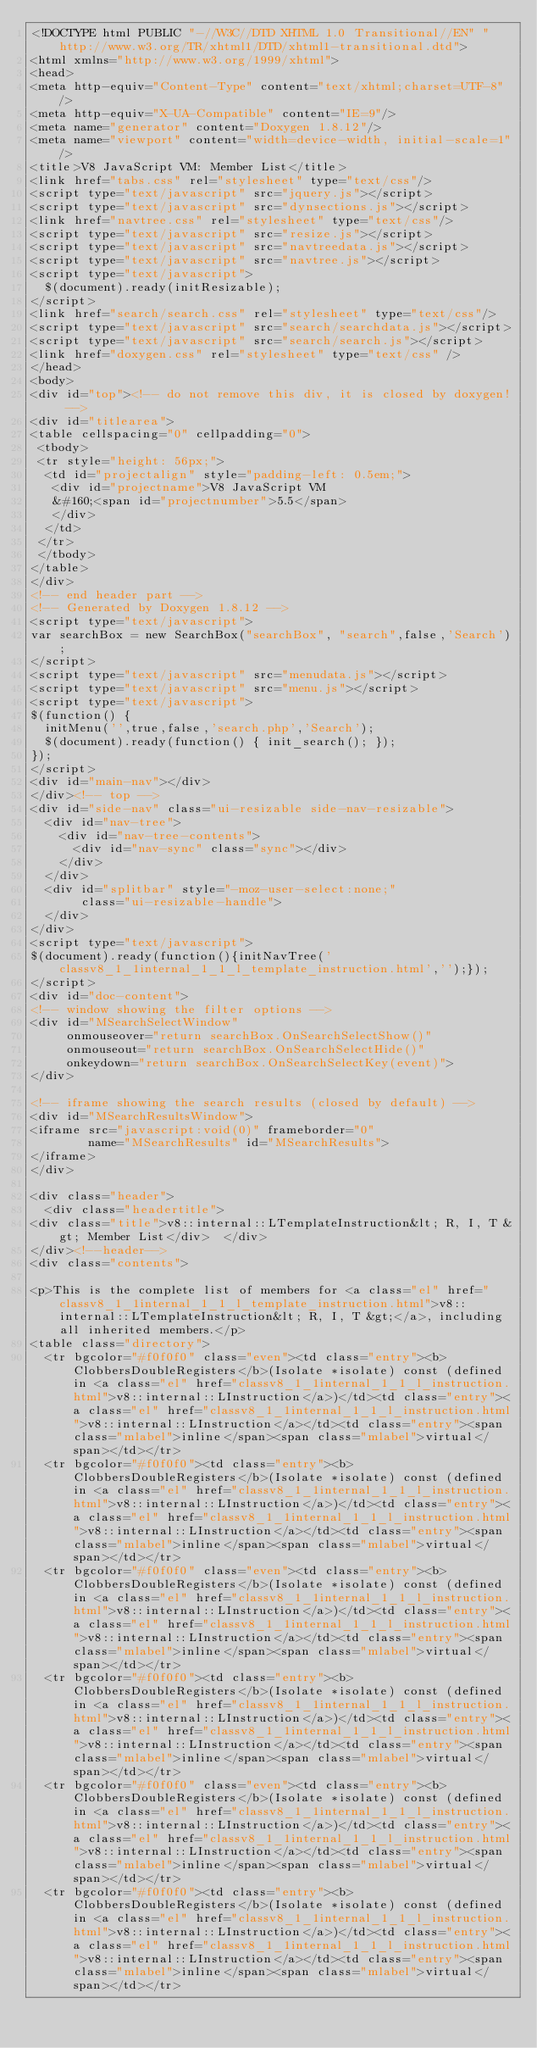Convert code to text. <code><loc_0><loc_0><loc_500><loc_500><_HTML_><!DOCTYPE html PUBLIC "-//W3C//DTD XHTML 1.0 Transitional//EN" "http://www.w3.org/TR/xhtml1/DTD/xhtml1-transitional.dtd">
<html xmlns="http://www.w3.org/1999/xhtml">
<head>
<meta http-equiv="Content-Type" content="text/xhtml;charset=UTF-8"/>
<meta http-equiv="X-UA-Compatible" content="IE=9"/>
<meta name="generator" content="Doxygen 1.8.12"/>
<meta name="viewport" content="width=device-width, initial-scale=1"/>
<title>V8 JavaScript VM: Member List</title>
<link href="tabs.css" rel="stylesheet" type="text/css"/>
<script type="text/javascript" src="jquery.js"></script>
<script type="text/javascript" src="dynsections.js"></script>
<link href="navtree.css" rel="stylesheet" type="text/css"/>
<script type="text/javascript" src="resize.js"></script>
<script type="text/javascript" src="navtreedata.js"></script>
<script type="text/javascript" src="navtree.js"></script>
<script type="text/javascript">
  $(document).ready(initResizable);
</script>
<link href="search/search.css" rel="stylesheet" type="text/css"/>
<script type="text/javascript" src="search/searchdata.js"></script>
<script type="text/javascript" src="search/search.js"></script>
<link href="doxygen.css" rel="stylesheet" type="text/css" />
</head>
<body>
<div id="top"><!-- do not remove this div, it is closed by doxygen! -->
<div id="titlearea">
<table cellspacing="0" cellpadding="0">
 <tbody>
 <tr style="height: 56px;">
  <td id="projectalign" style="padding-left: 0.5em;">
   <div id="projectname">V8 JavaScript VM
   &#160;<span id="projectnumber">5.5</span>
   </div>
  </td>
 </tr>
 </tbody>
</table>
</div>
<!-- end header part -->
<!-- Generated by Doxygen 1.8.12 -->
<script type="text/javascript">
var searchBox = new SearchBox("searchBox", "search",false,'Search');
</script>
<script type="text/javascript" src="menudata.js"></script>
<script type="text/javascript" src="menu.js"></script>
<script type="text/javascript">
$(function() {
  initMenu('',true,false,'search.php','Search');
  $(document).ready(function() { init_search(); });
});
</script>
<div id="main-nav"></div>
</div><!-- top -->
<div id="side-nav" class="ui-resizable side-nav-resizable">
  <div id="nav-tree">
    <div id="nav-tree-contents">
      <div id="nav-sync" class="sync"></div>
    </div>
  </div>
  <div id="splitbar" style="-moz-user-select:none;" 
       class="ui-resizable-handle">
  </div>
</div>
<script type="text/javascript">
$(document).ready(function(){initNavTree('classv8_1_1internal_1_1_l_template_instruction.html','');});
</script>
<div id="doc-content">
<!-- window showing the filter options -->
<div id="MSearchSelectWindow"
     onmouseover="return searchBox.OnSearchSelectShow()"
     onmouseout="return searchBox.OnSearchSelectHide()"
     onkeydown="return searchBox.OnSearchSelectKey(event)">
</div>

<!-- iframe showing the search results (closed by default) -->
<div id="MSearchResultsWindow">
<iframe src="javascript:void(0)" frameborder="0" 
        name="MSearchResults" id="MSearchResults">
</iframe>
</div>

<div class="header">
  <div class="headertitle">
<div class="title">v8::internal::LTemplateInstruction&lt; R, I, T &gt; Member List</div>  </div>
</div><!--header-->
<div class="contents">

<p>This is the complete list of members for <a class="el" href="classv8_1_1internal_1_1_l_template_instruction.html">v8::internal::LTemplateInstruction&lt; R, I, T &gt;</a>, including all inherited members.</p>
<table class="directory">
  <tr bgcolor="#f0f0f0" class="even"><td class="entry"><b>ClobbersDoubleRegisters</b>(Isolate *isolate) const (defined in <a class="el" href="classv8_1_1internal_1_1_l_instruction.html">v8::internal::LInstruction</a>)</td><td class="entry"><a class="el" href="classv8_1_1internal_1_1_l_instruction.html">v8::internal::LInstruction</a></td><td class="entry"><span class="mlabel">inline</span><span class="mlabel">virtual</span></td></tr>
  <tr bgcolor="#f0f0f0"><td class="entry"><b>ClobbersDoubleRegisters</b>(Isolate *isolate) const (defined in <a class="el" href="classv8_1_1internal_1_1_l_instruction.html">v8::internal::LInstruction</a>)</td><td class="entry"><a class="el" href="classv8_1_1internal_1_1_l_instruction.html">v8::internal::LInstruction</a></td><td class="entry"><span class="mlabel">inline</span><span class="mlabel">virtual</span></td></tr>
  <tr bgcolor="#f0f0f0" class="even"><td class="entry"><b>ClobbersDoubleRegisters</b>(Isolate *isolate) const (defined in <a class="el" href="classv8_1_1internal_1_1_l_instruction.html">v8::internal::LInstruction</a>)</td><td class="entry"><a class="el" href="classv8_1_1internal_1_1_l_instruction.html">v8::internal::LInstruction</a></td><td class="entry"><span class="mlabel">inline</span><span class="mlabel">virtual</span></td></tr>
  <tr bgcolor="#f0f0f0"><td class="entry"><b>ClobbersDoubleRegisters</b>(Isolate *isolate) const (defined in <a class="el" href="classv8_1_1internal_1_1_l_instruction.html">v8::internal::LInstruction</a>)</td><td class="entry"><a class="el" href="classv8_1_1internal_1_1_l_instruction.html">v8::internal::LInstruction</a></td><td class="entry"><span class="mlabel">inline</span><span class="mlabel">virtual</span></td></tr>
  <tr bgcolor="#f0f0f0" class="even"><td class="entry"><b>ClobbersDoubleRegisters</b>(Isolate *isolate) const (defined in <a class="el" href="classv8_1_1internal_1_1_l_instruction.html">v8::internal::LInstruction</a>)</td><td class="entry"><a class="el" href="classv8_1_1internal_1_1_l_instruction.html">v8::internal::LInstruction</a></td><td class="entry"><span class="mlabel">inline</span><span class="mlabel">virtual</span></td></tr>
  <tr bgcolor="#f0f0f0"><td class="entry"><b>ClobbersDoubleRegisters</b>(Isolate *isolate) const (defined in <a class="el" href="classv8_1_1internal_1_1_l_instruction.html">v8::internal::LInstruction</a>)</td><td class="entry"><a class="el" href="classv8_1_1internal_1_1_l_instruction.html">v8::internal::LInstruction</a></td><td class="entry"><span class="mlabel">inline</span><span class="mlabel">virtual</span></td></tr></code> 